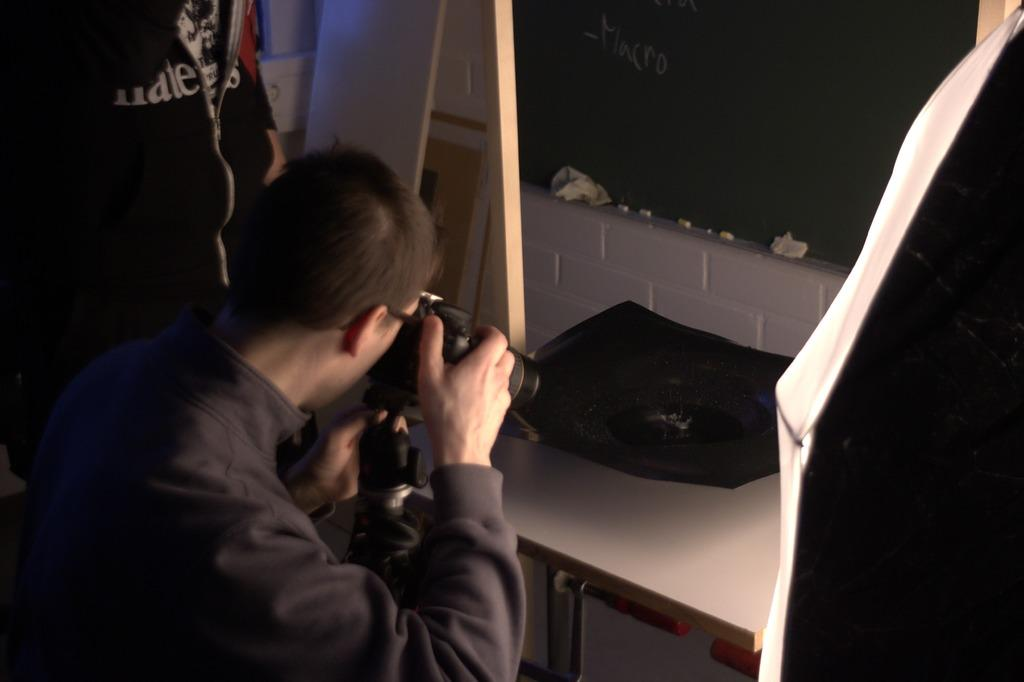Who is present in the image? There are people in the image. What is the man in the image doing? A man is taking a picture with a camera. What is on the table in front of the man? There is an object on a table in front of the man. What type of structure can be seen in the background of the image? There is no structure visible in the background of the image. Can you tell me how many people are walking in the image? There is no indication of anyone walking in the image. 